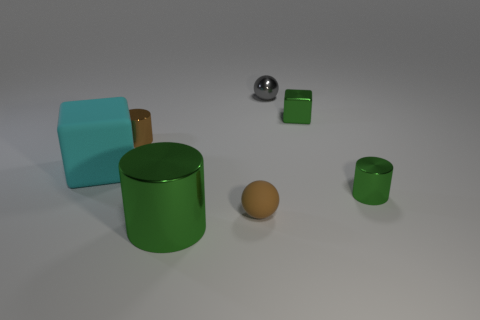What color is the tiny metal thing in front of the small brown shiny cylinder?
Your response must be concise. Green. Is there a tiny brown sphere to the right of the green metal cylinder that is left of the brown rubber thing?
Give a very brief answer. Yes. Is the number of small gray matte blocks less than the number of cyan matte blocks?
Your answer should be very brief. Yes. What is the material of the green cylinder on the right side of the big shiny thing that is in front of the small gray metal thing?
Make the answer very short. Metal. Is the size of the green cube the same as the cyan matte cube?
Offer a very short reply. No. What number of things are small things or brown metal cylinders?
Keep it short and to the point. 5. What size is the green shiny object that is right of the big green cylinder and in front of the big cyan block?
Offer a terse response. Small. Are there fewer tiny shiny blocks left of the small gray object than small brown matte things?
Offer a terse response. Yes. There is a gray thing that is made of the same material as the large green cylinder; what is its shape?
Provide a short and direct response. Sphere. There is a brown object left of the tiny brown matte thing; is its shape the same as the green metal object that is behind the small brown metallic cylinder?
Give a very brief answer. No. 